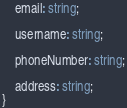<code> <loc_0><loc_0><loc_500><loc_500><_TypeScript_>
    email: string;

    username: string;

    phoneNumber: string;

    address: string;
}</code> 